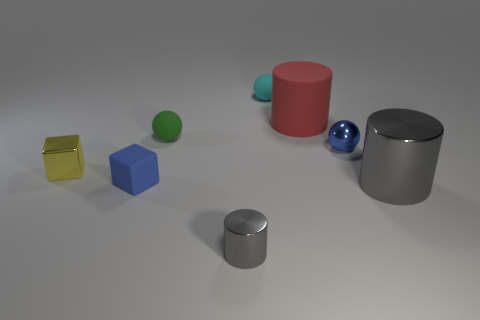There is a thing that is right of the small blue ball; is its color the same as the small shiny object in front of the blue block?
Your answer should be very brief. Yes. What shape is the shiny object that is the same color as the large shiny cylinder?
Offer a very short reply. Cylinder. What number of other objects are there of the same color as the big metal thing?
Provide a short and direct response. 1. What number of other things are there of the same size as the red matte cylinder?
Give a very brief answer. 1. Is the number of metal things that are on the left side of the matte block the same as the number of small shiny cylinders that are left of the cyan ball?
Your answer should be compact. Yes. There is another rubber object that is the same shape as the yellow object; what is its color?
Give a very brief answer. Blue. Do the small metal object in front of the small yellow thing and the small matte cube have the same color?
Offer a terse response. No. The other shiny object that is the same shape as the big gray metal thing is what size?
Offer a terse response. Small. How many big things are made of the same material as the tiny blue ball?
Your answer should be very brief. 1. Is there a yellow metal object that is left of the big object that is in front of the small blue object that is in front of the small yellow shiny thing?
Keep it short and to the point. Yes. 